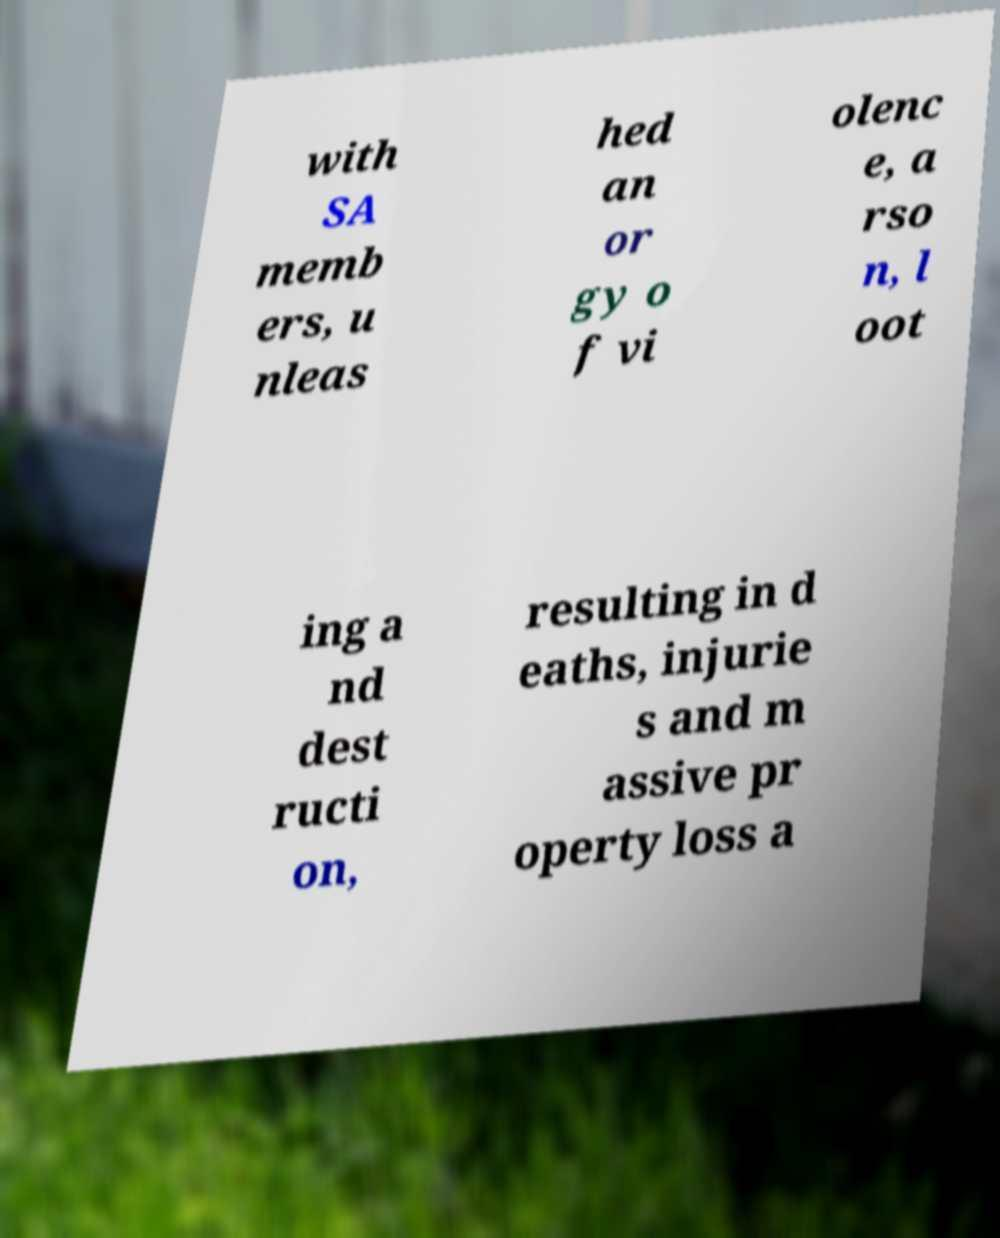I need the written content from this picture converted into text. Can you do that? with SA memb ers, u nleas hed an or gy o f vi olenc e, a rso n, l oot ing a nd dest ructi on, resulting in d eaths, injurie s and m assive pr operty loss a 